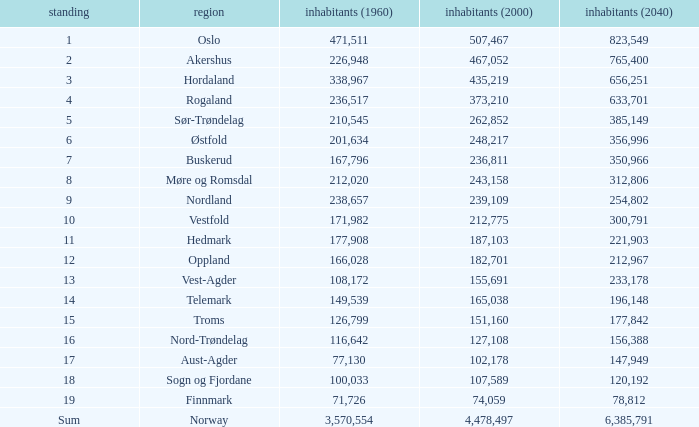What was the population of a county in 1960 that had a population of 467,052 in 2000 and 78,812 in 2040? None. 